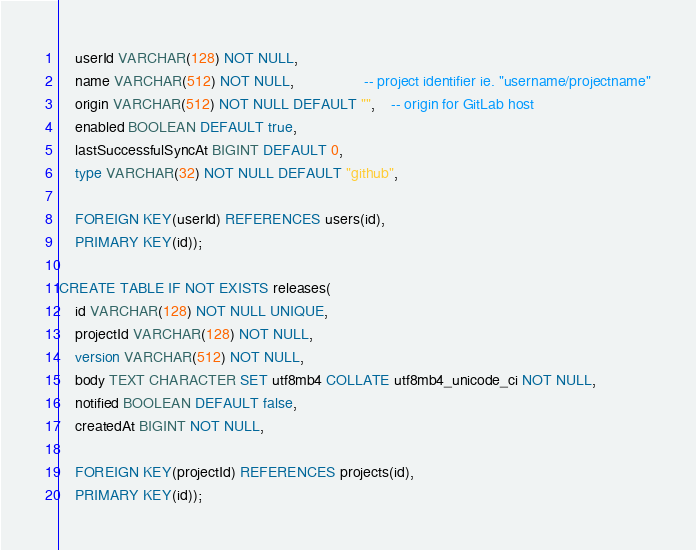<code> <loc_0><loc_0><loc_500><loc_500><_SQL_>    userId VARCHAR(128) NOT NULL,
    name VARCHAR(512) NOT NULL,                 -- project identifier ie. "username/projectname"
    origin VARCHAR(512) NOT NULL DEFAULT "",    -- origin for GitLab host
    enabled BOOLEAN DEFAULT true,
    lastSuccessfulSyncAt BIGINT DEFAULT 0,
    type VARCHAR(32) NOT NULL DEFAULT "github",

    FOREIGN KEY(userId) REFERENCES users(id),
    PRIMARY KEY(id));

CREATE TABLE IF NOT EXISTS releases(
    id VARCHAR(128) NOT NULL UNIQUE,
    projectId VARCHAR(128) NOT NULL,
    version VARCHAR(512) NOT NULL,
    body TEXT CHARACTER SET utf8mb4 COLLATE utf8mb4_unicode_ci NOT NULL,
    notified BOOLEAN DEFAULT false,
    createdAt BIGINT NOT NULL,

    FOREIGN KEY(projectId) REFERENCES projects(id),
    PRIMARY KEY(id));
</code> 